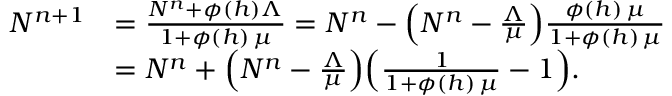Convert formula to latex. <formula><loc_0><loc_0><loc_500><loc_500>\begin{array} { r l } { N ^ { n + 1 } } & { = \frac { N ^ { n } + \phi ( h ) \Lambda } { 1 + \phi ( h ) \, \mu } = N ^ { n } - \left ( N ^ { n } - \frac { \Lambda } { \mu } \right ) \frac { \phi ( h ) \, \mu } { 1 + \phi ( h ) \, \mu } } \\ & { = N ^ { n } + \left ( N ^ { n } - \frac { \Lambda } { \mu } \right ) \left ( \frac { 1 } { 1 + \phi ( h ) \, \mu } - 1 \right ) . } \end{array}</formula> 